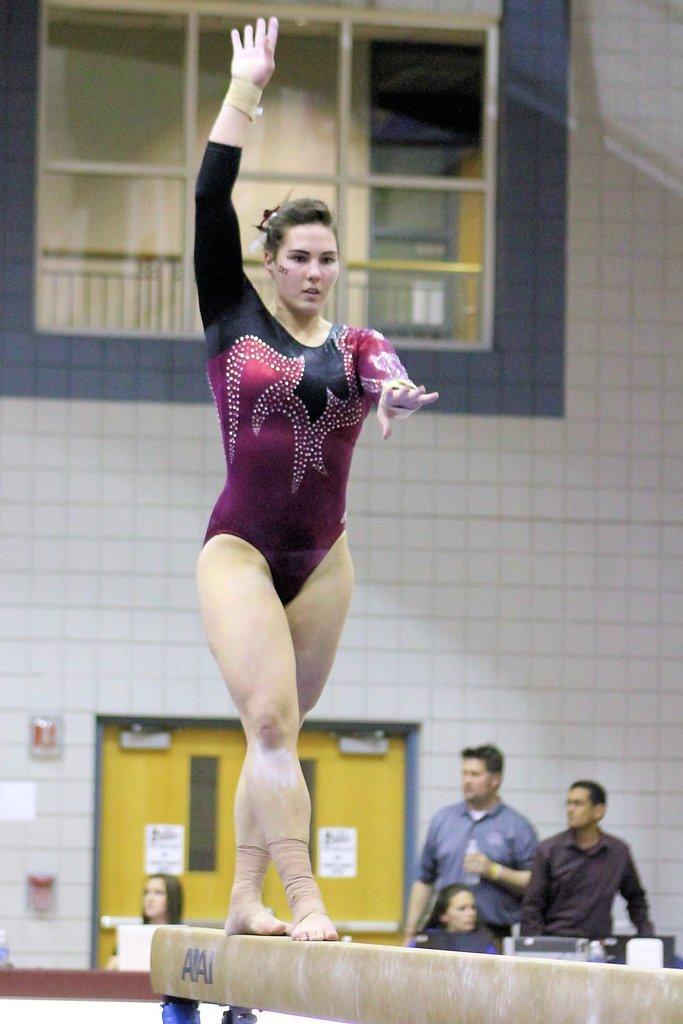In one or two sentences, can you explain what this image depicts? In the center of the picture there is a woman on the balance beam. In the background there are people, door, fire alarm and wall. At the top there is a glass window, outside the window it is building. 